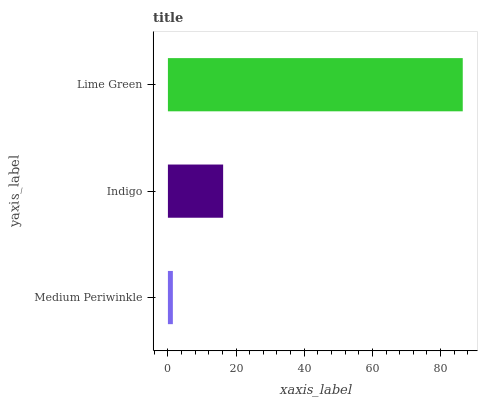Is Medium Periwinkle the minimum?
Answer yes or no. Yes. Is Lime Green the maximum?
Answer yes or no. Yes. Is Indigo the minimum?
Answer yes or no. No. Is Indigo the maximum?
Answer yes or no. No. Is Indigo greater than Medium Periwinkle?
Answer yes or no. Yes. Is Medium Periwinkle less than Indigo?
Answer yes or no. Yes. Is Medium Periwinkle greater than Indigo?
Answer yes or no. No. Is Indigo less than Medium Periwinkle?
Answer yes or no. No. Is Indigo the high median?
Answer yes or no. Yes. Is Indigo the low median?
Answer yes or no. Yes. Is Medium Periwinkle the high median?
Answer yes or no. No. Is Medium Periwinkle the low median?
Answer yes or no. No. 